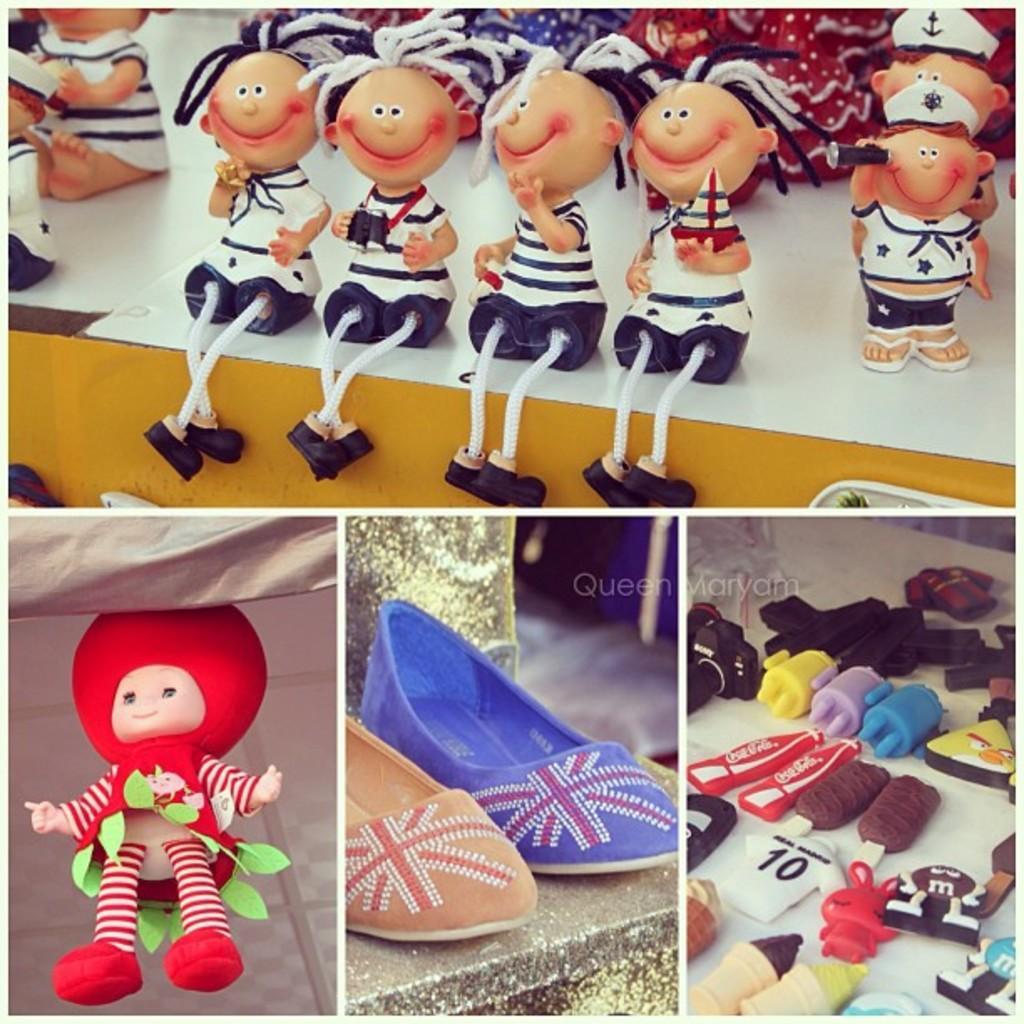In one or two sentences, can you explain what this image depicts? This is a collage picture and in this picture we can see shoes on a platform, toys and some objects. 